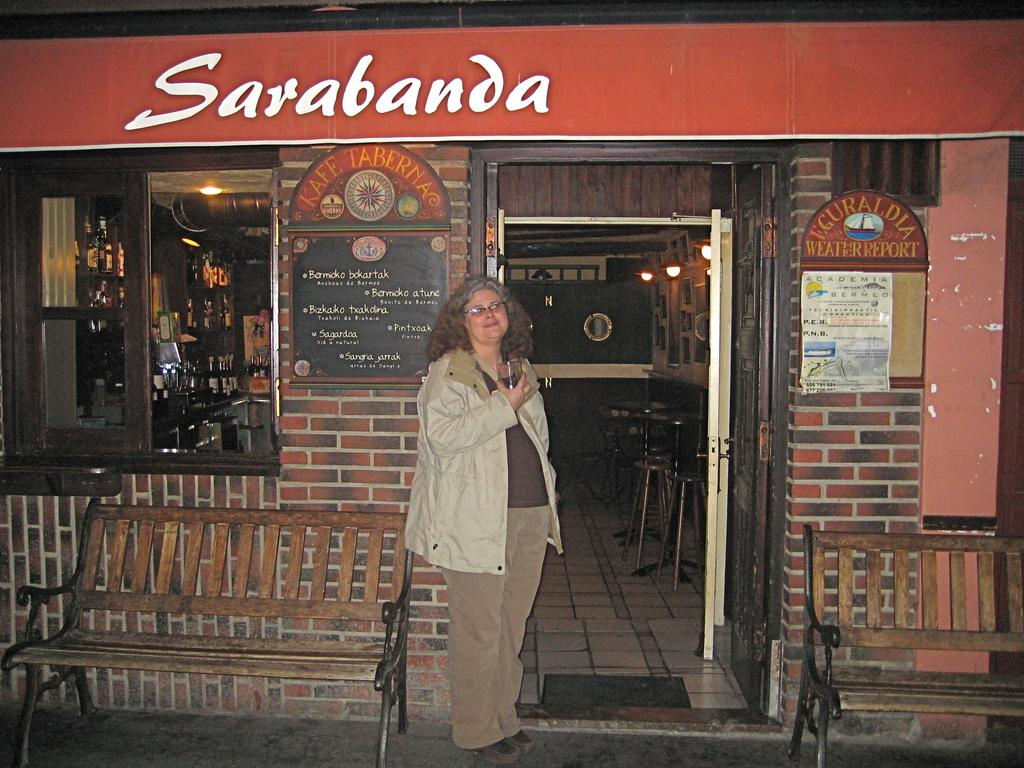What is the person in the image doing? The person is standing and holding something in the image. What type of furniture can be seen in the image? There are benches, stools, and tables in the image. What type of lighting is present in the image? There are lights in the image. What type of containers are visible in the image? There are bottles in the image. What type of signage or display is present in the image? There are boards in the image. Are there any other objects present in the image besides the ones mentioned? Yes, there are other objects present in the image. What type of stocking is the person wearing in the image? There is no information about the person's stockings in the image, so we cannot determine if they are wearing any. What is the son of the person doing in the image? There is no mention of a son or any other person besides the one standing and holding something in the image. What is the acoustics like in the image? The provided facts do not give any information about the acoustics in the image, so we cannot determine how sound is being transmitted or perceived. 